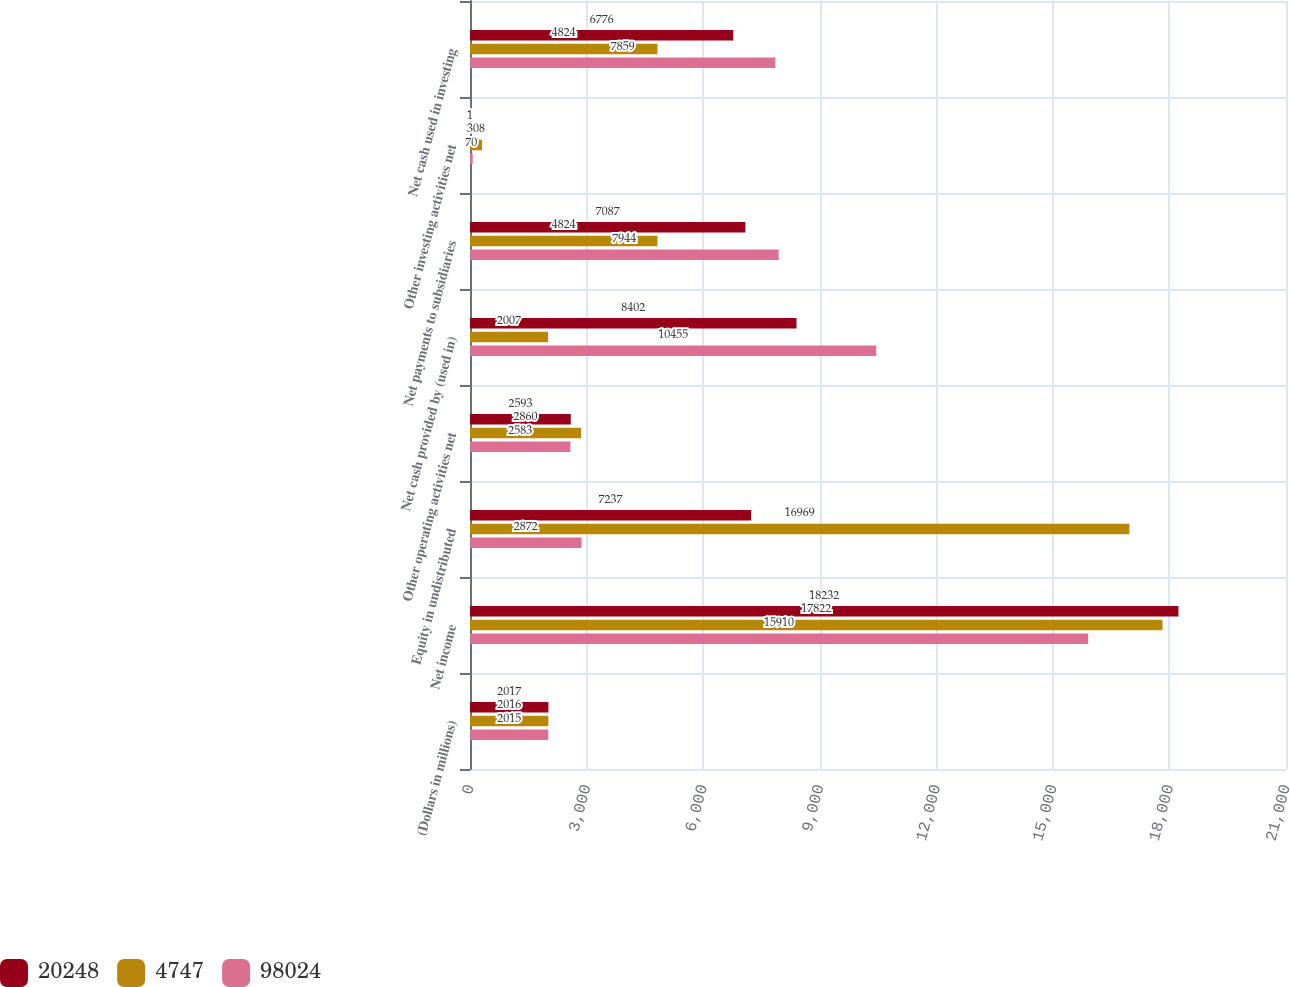Convert chart to OTSL. <chart><loc_0><loc_0><loc_500><loc_500><stacked_bar_chart><ecel><fcel>(Dollars in millions)<fcel>Net income<fcel>Equity in undistributed<fcel>Other operating activities net<fcel>Net cash provided by (used in)<fcel>Net payments to subsidiaries<fcel>Other investing activities net<fcel>Net cash used in investing<nl><fcel>20248<fcel>2017<fcel>18232<fcel>7237<fcel>2593<fcel>8402<fcel>7087<fcel>1<fcel>6776<nl><fcel>4747<fcel>2016<fcel>17822<fcel>16969<fcel>2860<fcel>2007<fcel>4824<fcel>308<fcel>4824<nl><fcel>98024<fcel>2015<fcel>15910<fcel>2872<fcel>2583<fcel>10455<fcel>7944<fcel>70<fcel>7859<nl></chart> 